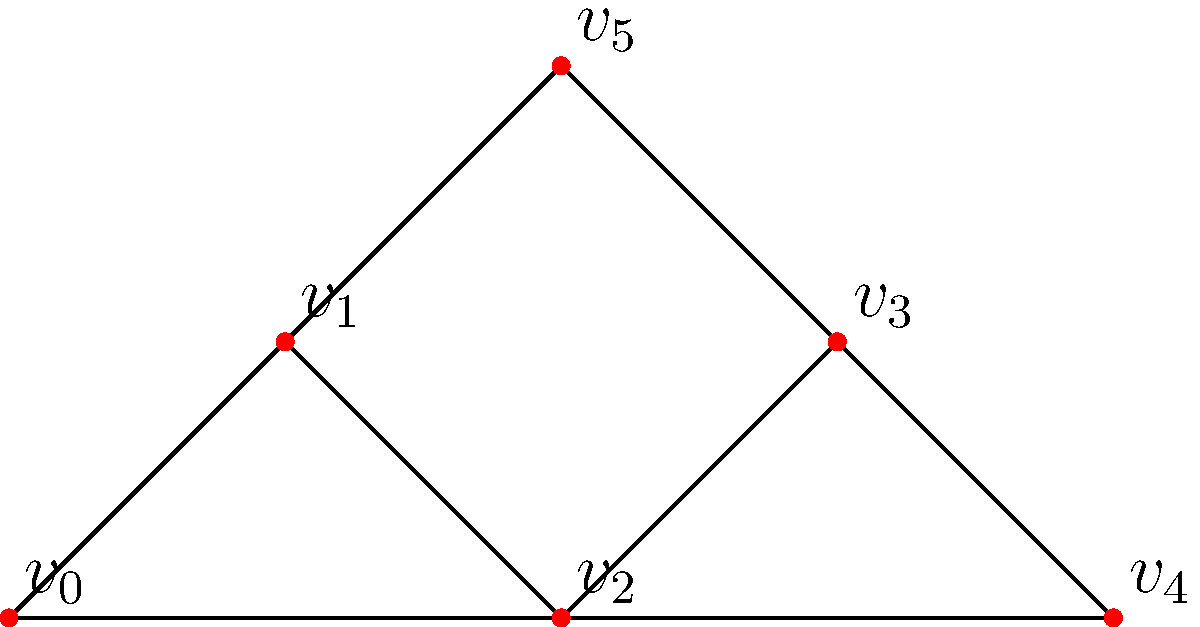In your investigation of a financial fraud network, you've identified six key individuals represented by vertices $v_0$ to $v_5$ in the graph above. The edges represent financial transactions or communication links between these individuals. Which vertex has the highest betweenness centrality, potentially indicating the most critical player in facilitating the fraud? To determine the vertex with the highest betweenness centrality, we need to follow these steps:

1) Understand betweenness centrality: It measures how often a node appears on the shortest paths between other nodes in the network.

2) Identify all shortest paths between pairs of nodes:
   - $v_0$ to $v_4$: $v_0 - v_2 - v_4$
   - $v_0$ to $v_3$: $v_0 - v_1 - v_3$ or $v_0 - v_2 - v_3$
   - $v_0$ to $v_5$: $v_0 - v_1 - v_5$
   - $v_1$ to $v_4$: $v_1 - v_2 - v_4$ or $v_1 - v_3 - v_4$
   - $v_1$ to $v_5$: $v_1 - v_5$
   - $v_2$ to $v_5$: $v_2 - v_1 - v_5$ or $v_2 - v_3 - v_5$
   - Other paths can be similarly identified

3) Count how many times each vertex appears on these shortest paths:
   $v_0$: 3 times
   $v_1$: 6 times
   $v_2$: 8 times
   $v_3$: 6 times
   $v_4$: 3 times
   $v_5$: 3 times

4) Identify the vertex that appears most frequently: $v_2$

Therefore, $v_2$ has the highest betweenness centrality, indicating it's the most critical player in facilitating the fraud network.
Answer: $v_2$ 